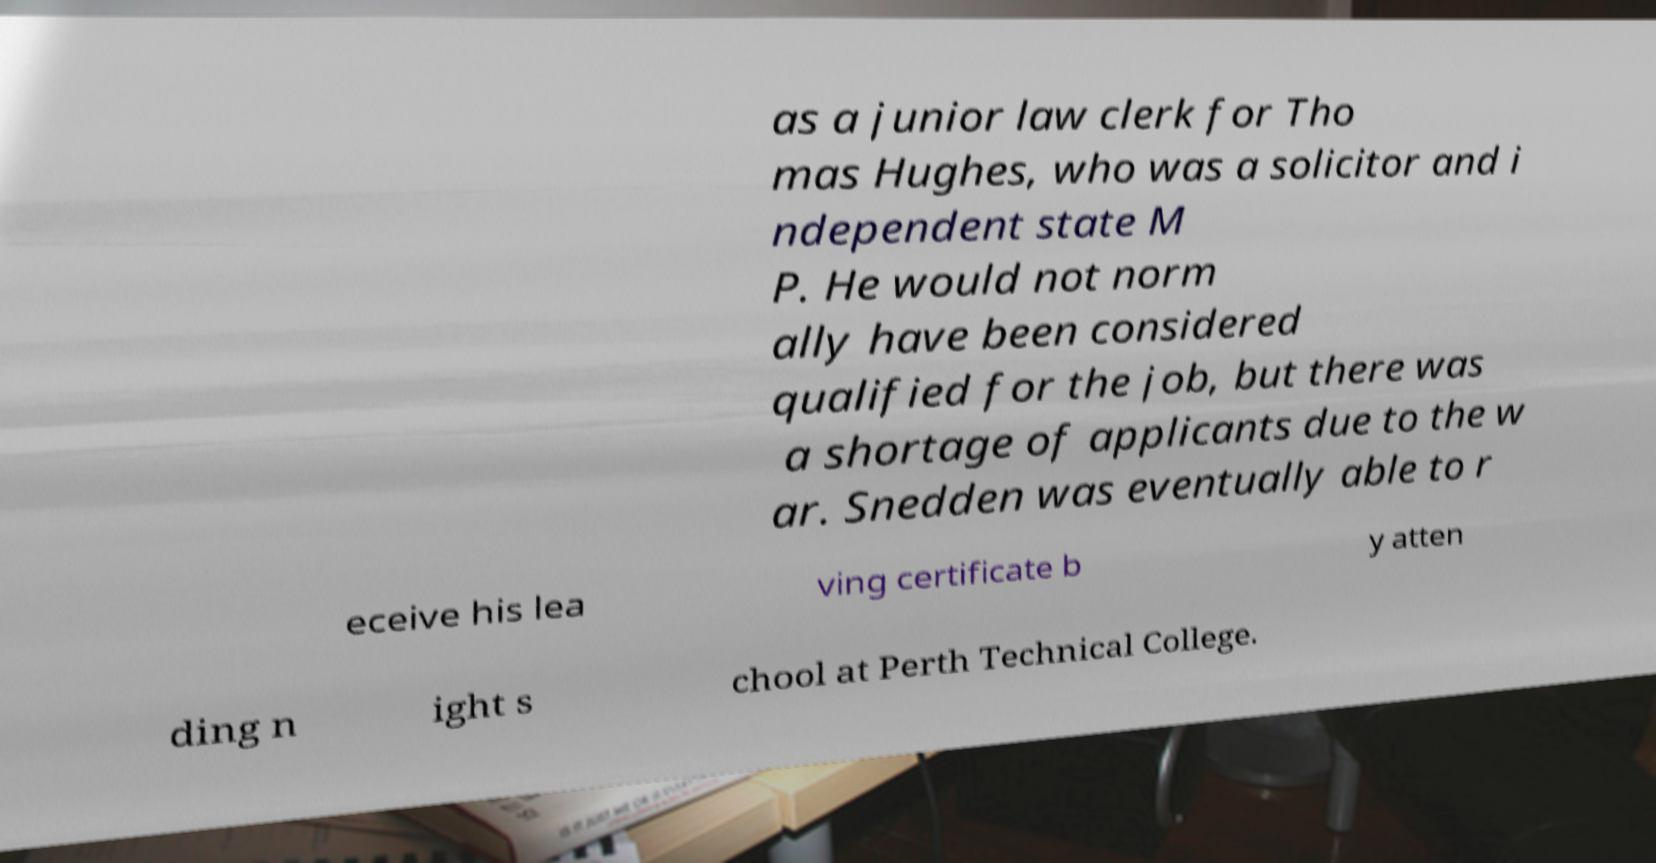Please identify and transcribe the text found in this image. as a junior law clerk for Tho mas Hughes, who was a solicitor and i ndependent state M P. He would not norm ally have been considered qualified for the job, but there was a shortage of applicants due to the w ar. Snedden was eventually able to r eceive his lea ving certificate b y atten ding n ight s chool at Perth Technical College. 